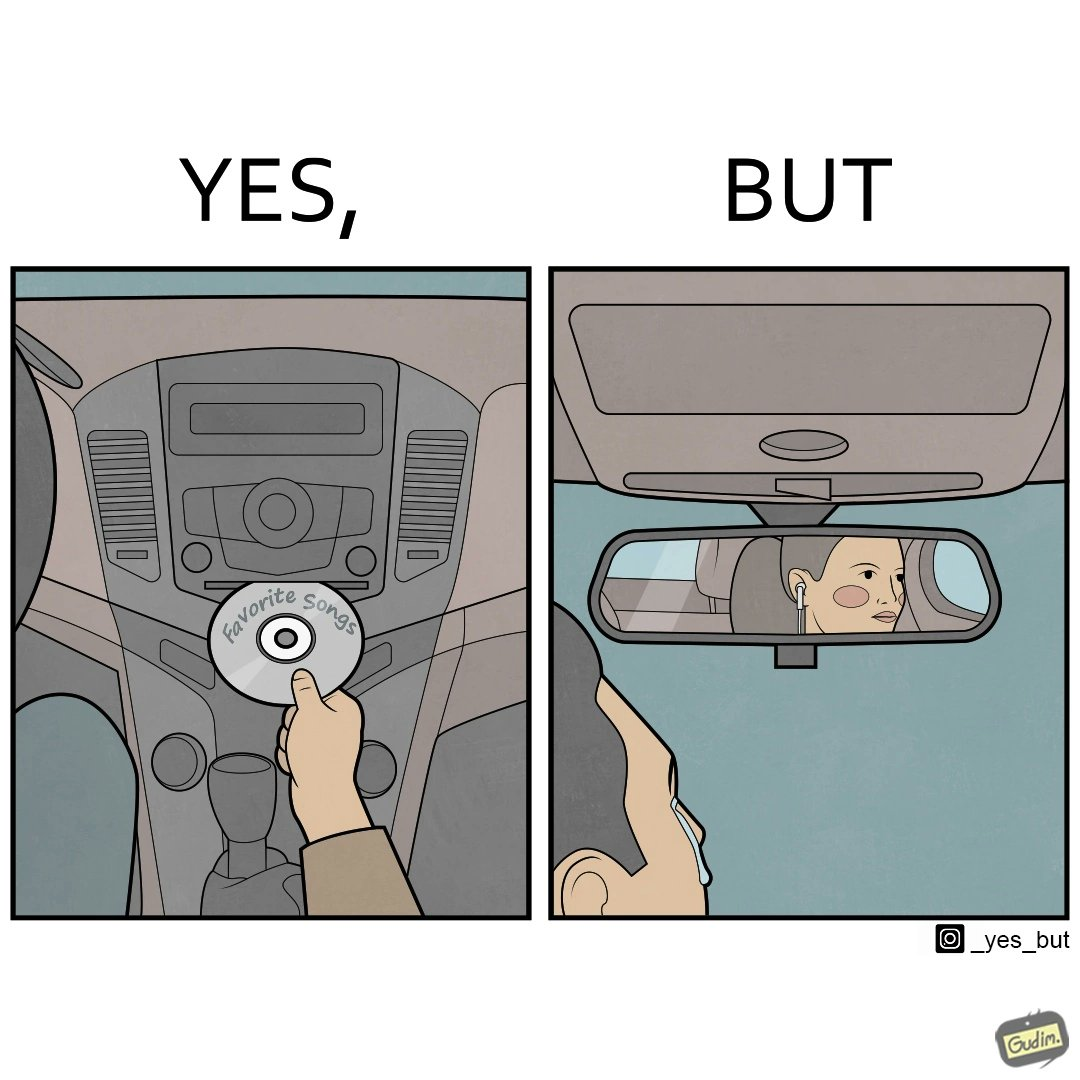What does this image depict? The image is funny, as the driver of the car inserts a CD named "Favorite Songs" into the CD player for the passenger, but the driver is sad on seeing the passenger in the back seat listening to something else on earphones instead. 